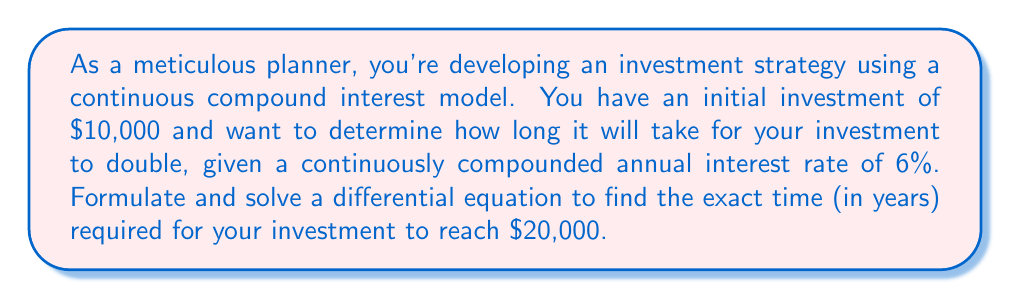Help me with this question. Let's approach this problem step-by-step:

1) Let $P(t)$ be the principal amount at time $t$ (in years).

2) The rate of change of the principal with respect to time is proportional to the principal itself:

   $$\frac{dP}{dt} = rP$$

   where $r$ is the continuous interest rate (0.06 in this case).

3) This is a separable differential equation. Let's solve it:

   $$\frac{dP}{P} = r dt$$

4) Integrating both sides:

   $$\int \frac{dP}{P} = \int r dt$$

   $$\ln|P| = rt + C$$

5) Taking the exponential of both sides:

   $$P = e^{rt + C} = e^C e^{rt}$$

6) Let $P_0$ be the initial principal. When $t = 0$, $P = P_0$:

   $$P_0 = e^C$$

7) Therefore, the general solution is:

   $$P = P_0 e^{rt}$$

8) Now, let's use the specific values. We want to find $t$ when $P = 2P_0$:

   $$2P_0 = P_0 e^{0.06t}$$

9) Dividing both sides by $P_0$:

   $$2 = e^{0.06t}$$

10) Taking the natural logarithm of both sides:

    $$\ln(2) = 0.06t$$

11) Solving for $t$:

    $$t = \frac{\ln(2)}{0.06} \approx 11.55 \text{ years}$$
Answer: The exact time required for the investment to double is $\frac{\ln(2)}{0.06} \approx 11.55$ years. 